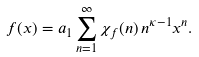Convert formula to latex. <formula><loc_0><loc_0><loc_500><loc_500>f ( x ) & = a _ { 1 } \sum _ { n = 1 } ^ { \infty } \chi _ { f } ( n ) \, n ^ { \kappa - 1 } x ^ { n } .</formula> 